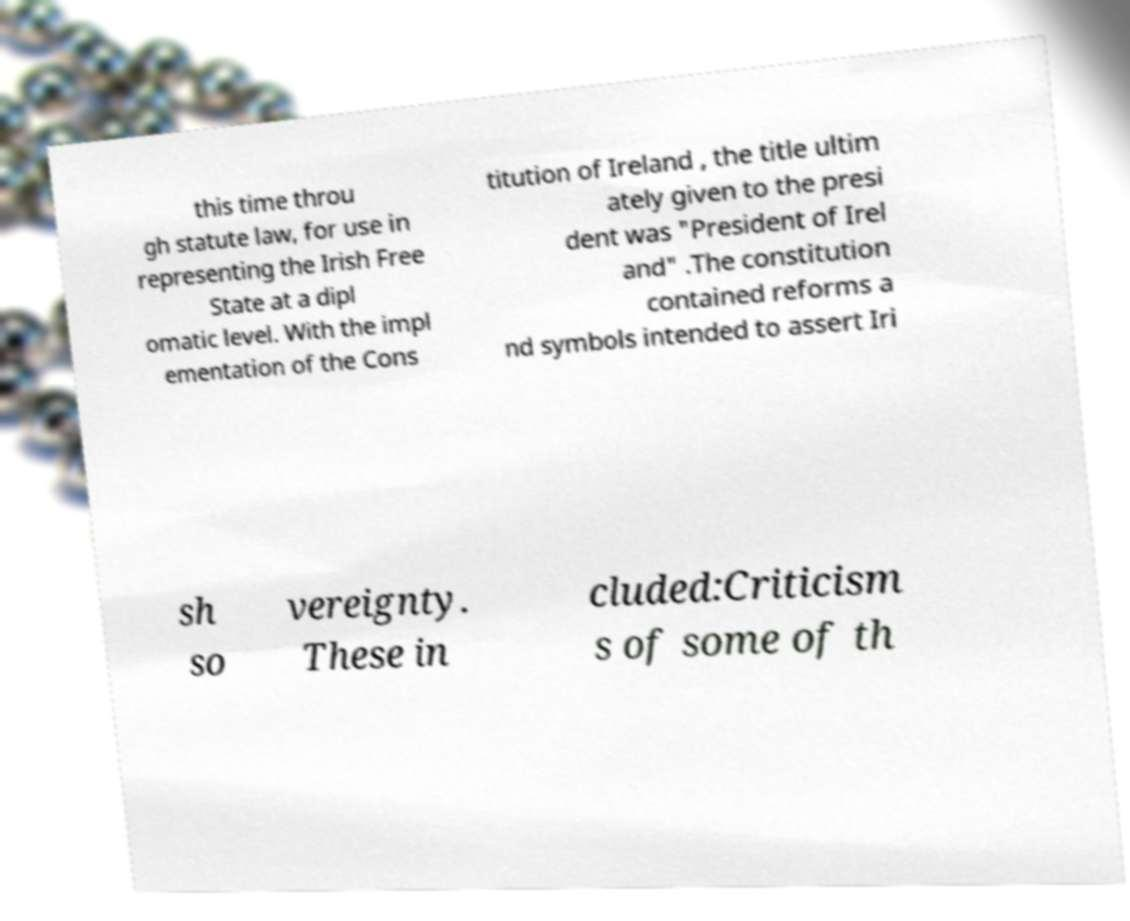Could you extract and type out the text from this image? this time throu gh statute law, for use in representing the Irish Free State at a dipl omatic level. With the impl ementation of the Cons titution of Ireland , the title ultim ately given to the presi dent was "President of Irel and" .The constitution contained reforms a nd symbols intended to assert Iri sh so vereignty. These in cluded:Criticism s of some of th 